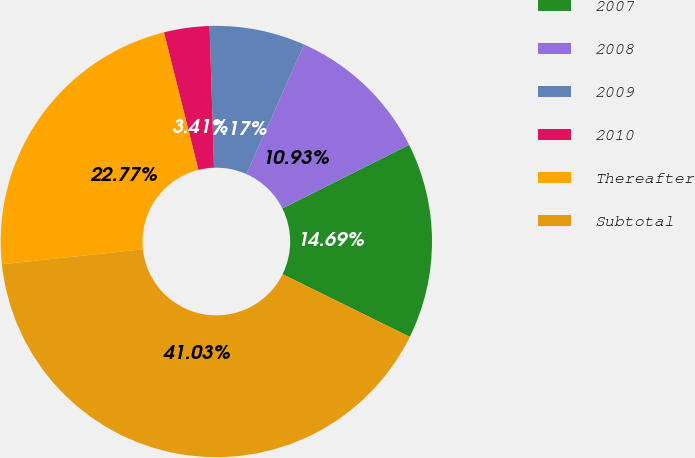Convert chart to OTSL. <chart><loc_0><loc_0><loc_500><loc_500><pie_chart><fcel>2007<fcel>2008<fcel>2009<fcel>2010<fcel>Thereafter<fcel>Subtotal<nl><fcel>14.69%<fcel>10.93%<fcel>7.17%<fcel>3.41%<fcel>22.77%<fcel>41.03%<nl></chart> 